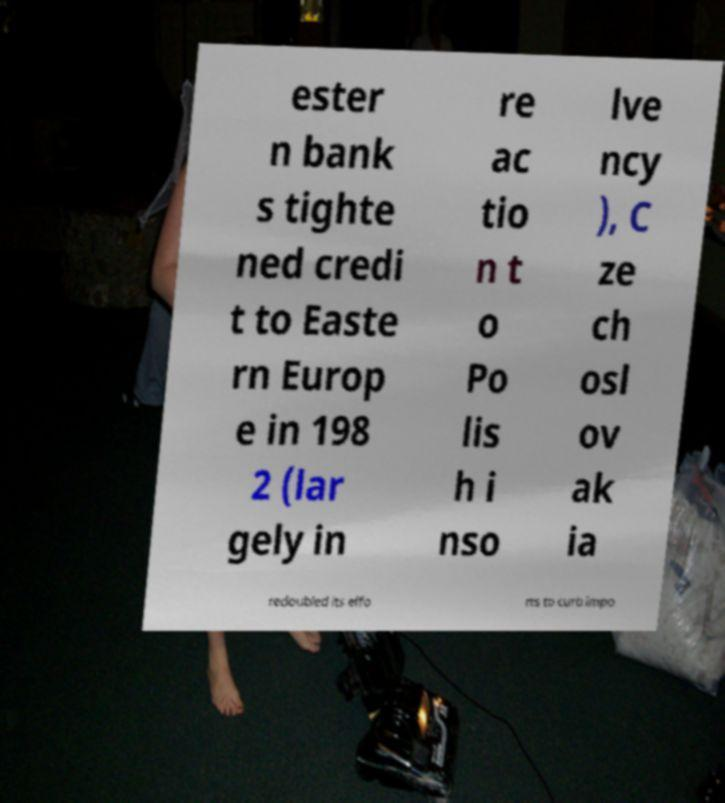There's text embedded in this image that I need extracted. Can you transcribe it verbatim? ester n bank s tighte ned credi t to Easte rn Europ e in 198 2 (lar gely in re ac tio n t o Po lis h i nso lve ncy ), C ze ch osl ov ak ia redoubled its effo rts to curb impo 